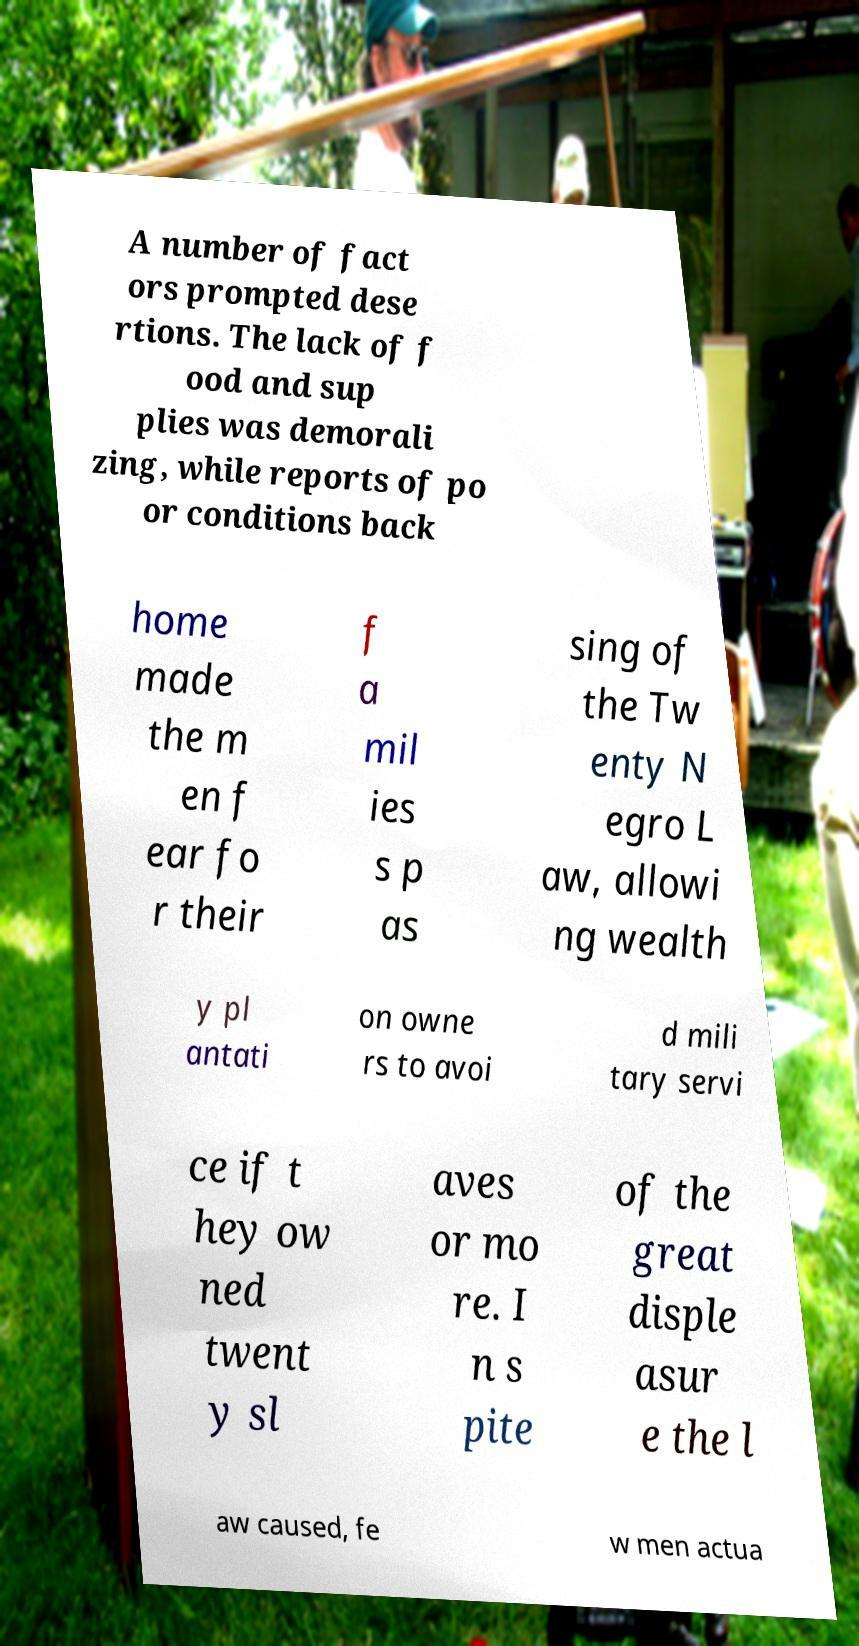Please identify and transcribe the text found in this image. A number of fact ors prompted dese rtions. The lack of f ood and sup plies was demorali zing, while reports of po or conditions back home made the m en f ear fo r their f a mil ies s p as sing of the Tw enty N egro L aw, allowi ng wealth y pl antati on owne rs to avoi d mili tary servi ce if t hey ow ned twent y sl aves or mo re. I n s pite of the great disple asur e the l aw caused, fe w men actua 